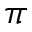Convert formula to latex. <formula><loc_0><loc_0><loc_500><loc_500>\pi</formula> 